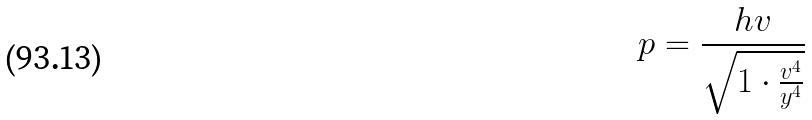Convert formula to latex. <formula><loc_0><loc_0><loc_500><loc_500>p = \frac { h v } { \sqrt { 1 \cdot \frac { v ^ { 4 } } { y ^ { 4 } } } }</formula> 